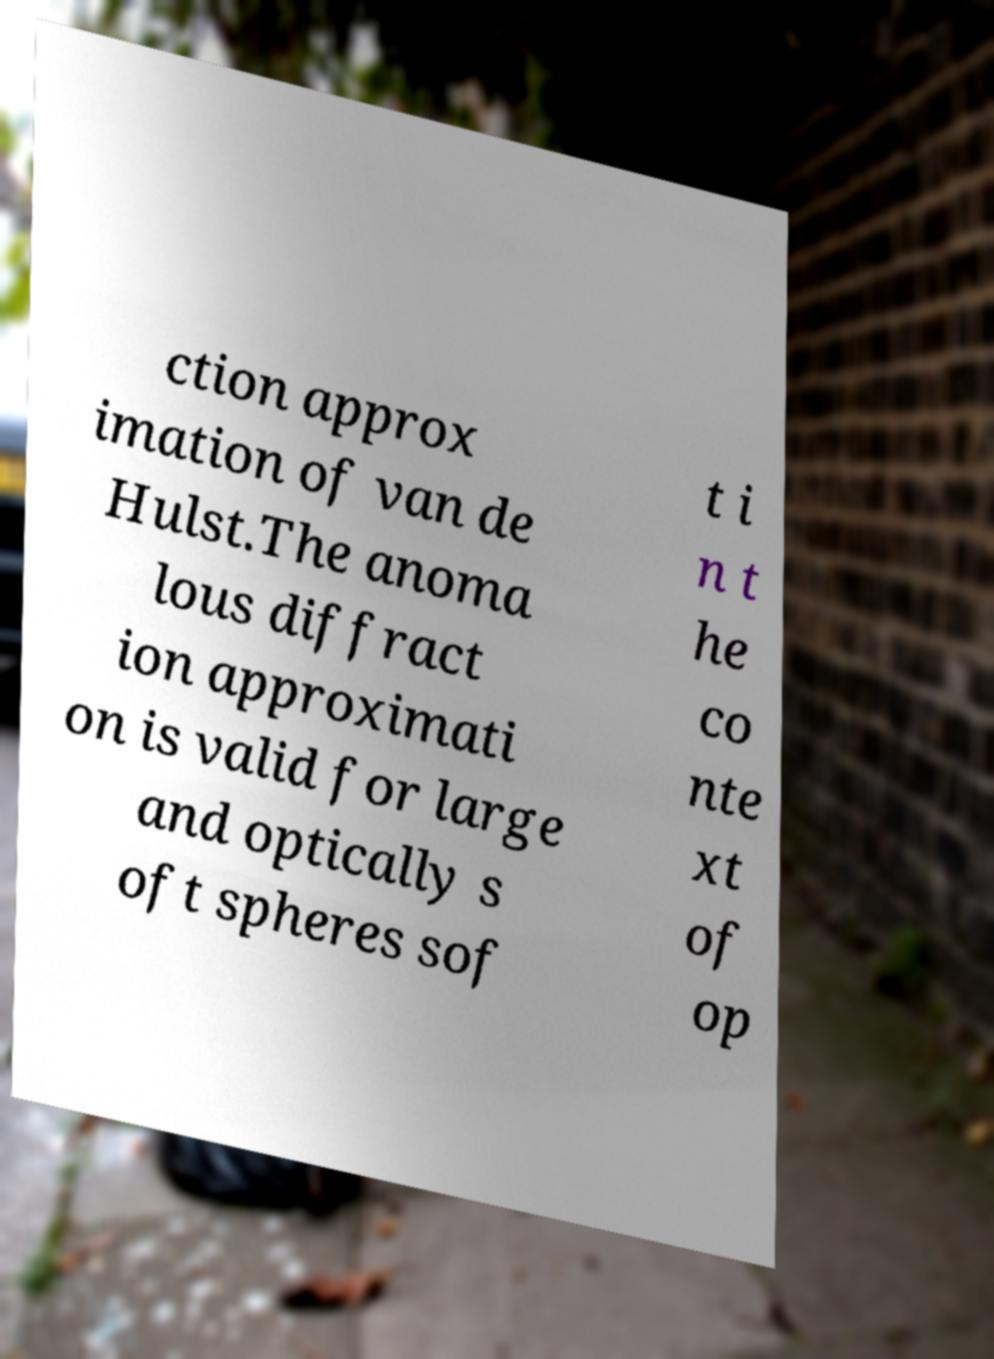There's text embedded in this image that I need extracted. Can you transcribe it verbatim? ction approx imation of van de Hulst.The anoma lous diffract ion approximati on is valid for large and optically s oft spheres sof t i n t he co nte xt of op 